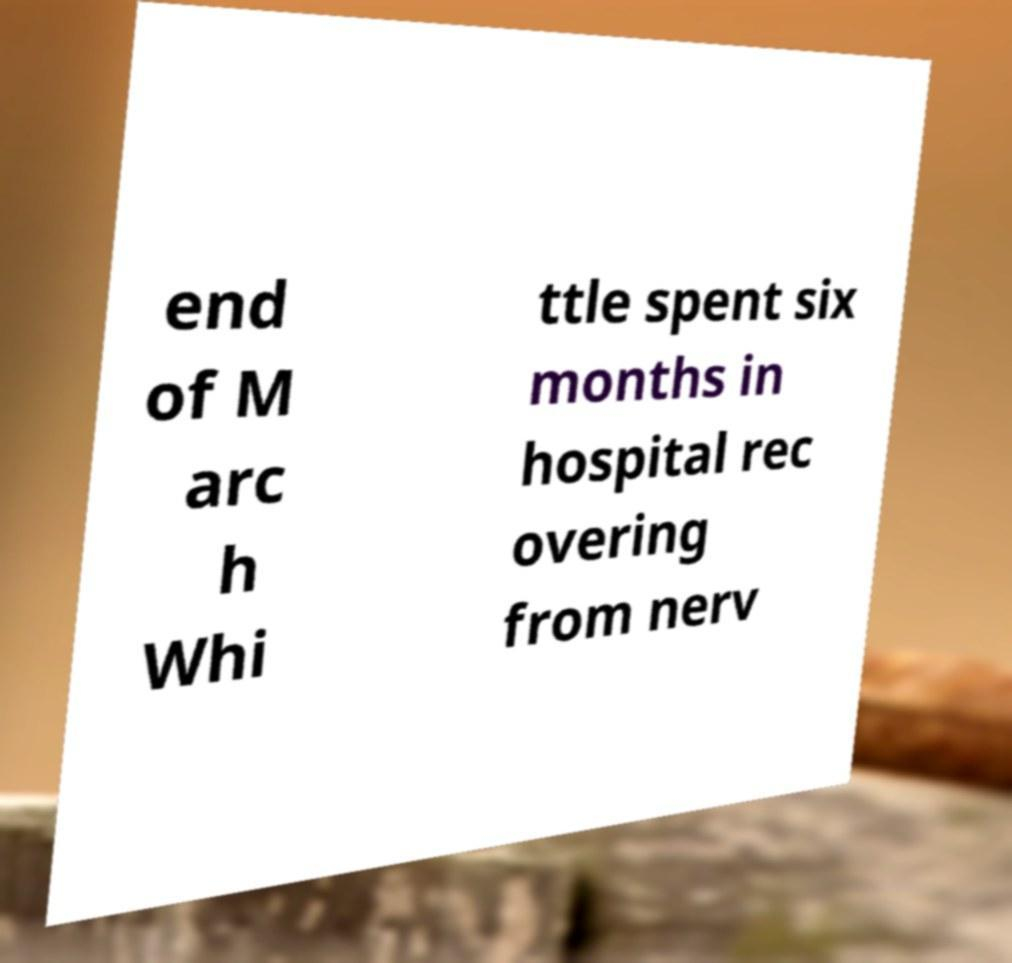Could you extract and type out the text from this image? end of M arc h Whi ttle spent six months in hospital rec overing from nerv 